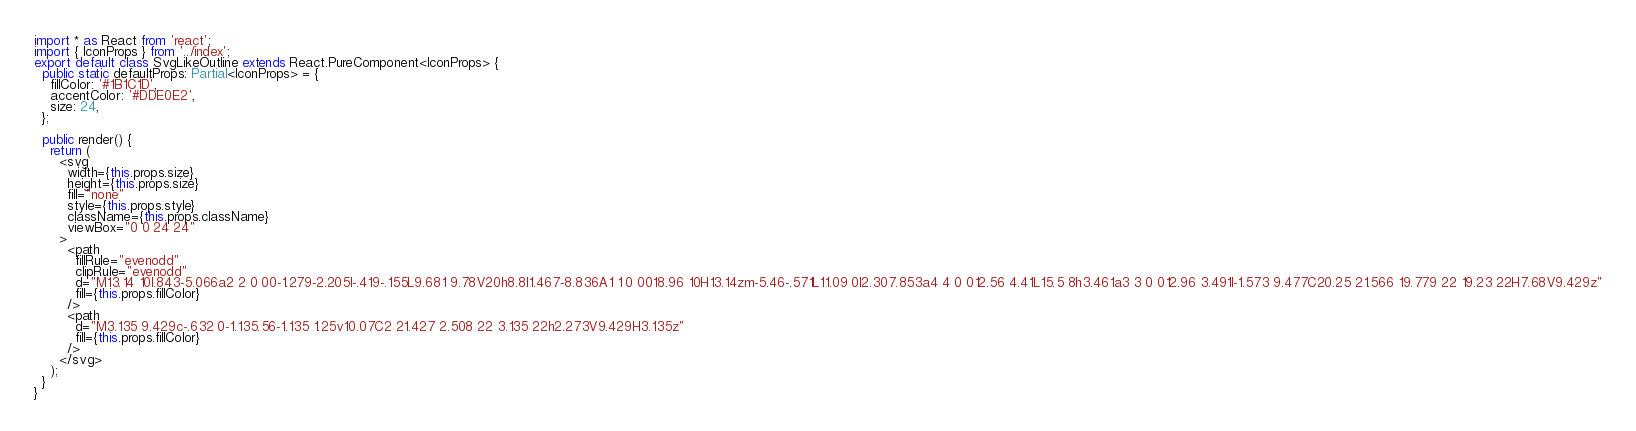<code> <loc_0><loc_0><loc_500><loc_500><_TypeScript_>import * as React from 'react';
import { IconProps } from '../index';
export default class SvgLikeOutline extends React.PureComponent<IconProps> {
  public static defaultProps: Partial<IconProps> = {
    fillColor: '#1B1C1D',
    accentColor: '#DDE0E2',
    size: 24,
  };

  public render() {
    return (
      <svg
        width={this.props.size}
        height={this.props.size}
        fill="none"
        style={this.props.style}
        className={this.props.className}
        viewBox="0 0 24 24"
      >
        <path
          fillRule="evenodd"
          clipRule="evenodd"
          d="M13.14 10l.843-5.066a2 2 0 00-1.279-2.205l-.419-.155L9.681 9.78V20h8.8l1.467-8.836A1 1 0 0018.96 10H13.14zm-5.46-.571L11.09 0l2.307.853a4 4 0 012.56 4.41L15.5 8h3.461a3 3 0 012.96 3.491l-1.573 9.477C20.25 21.566 19.779 22 19.23 22H7.68V9.429z"
          fill={this.props.fillColor}
        />
        <path
          d="M3.135 9.429c-.632 0-1.135.56-1.135 1.25v10.07C2 21.427 2.508 22 3.135 22h2.273V9.429H3.135z"
          fill={this.props.fillColor}
        />
      </svg>
    );
  }
}
</code> 